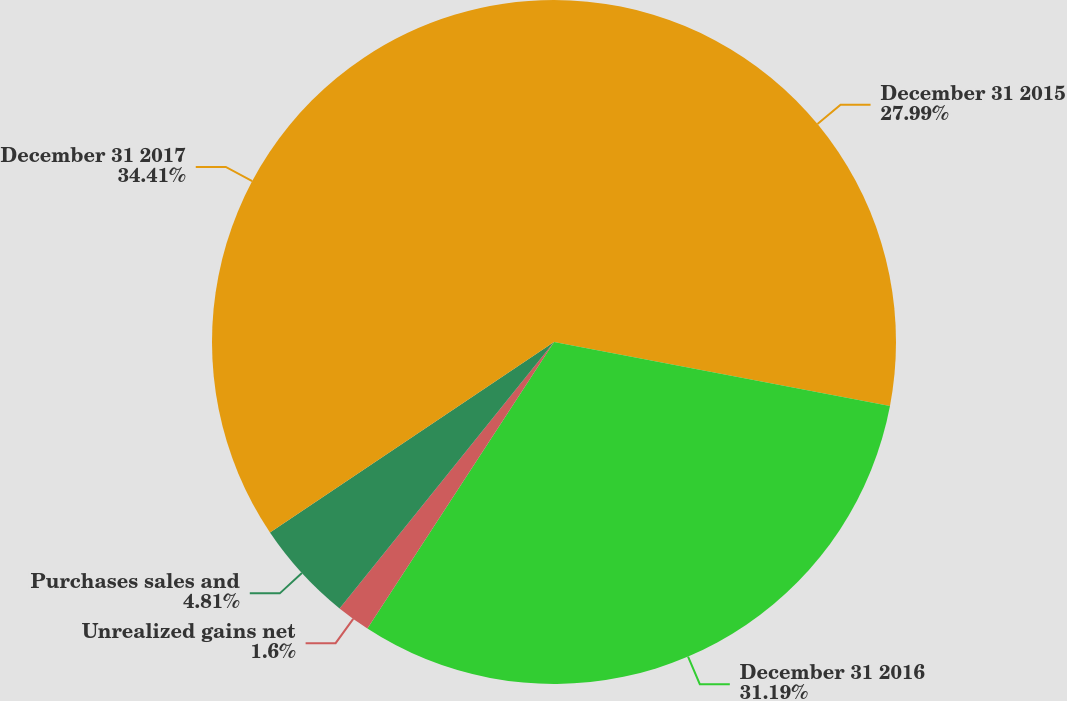Convert chart to OTSL. <chart><loc_0><loc_0><loc_500><loc_500><pie_chart><fcel>December 31 2015<fcel>December 31 2016<fcel>Unrealized gains net<fcel>Purchases sales and<fcel>December 31 2017<nl><fcel>27.99%<fcel>31.19%<fcel>1.6%<fcel>4.81%<fcel>34.4%<nl></chart> 